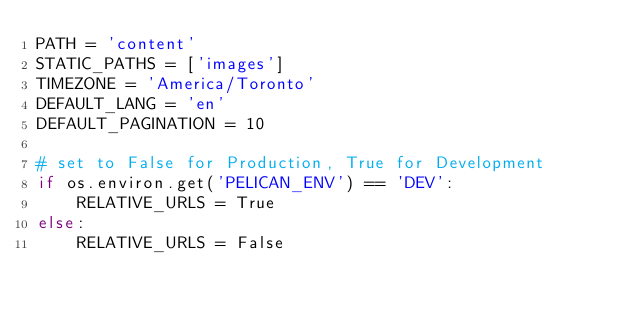<code> <loc_0><loc_0><loc_500><loc_500><_Python_>PATH = 'content'
STATIC_PATHS = ['images']
TIMEZONE = 'America/Toronto'
DEFAULT_LANG = 'en'
DEFAULT_PAGINATION = 10

# set to False for Production, True for Development
if os.environ.get('PELICAN_ENV') == 'DEV':
    RELATIVE_URLS = True
else:
    RELATIVE_URLS = False</code> 